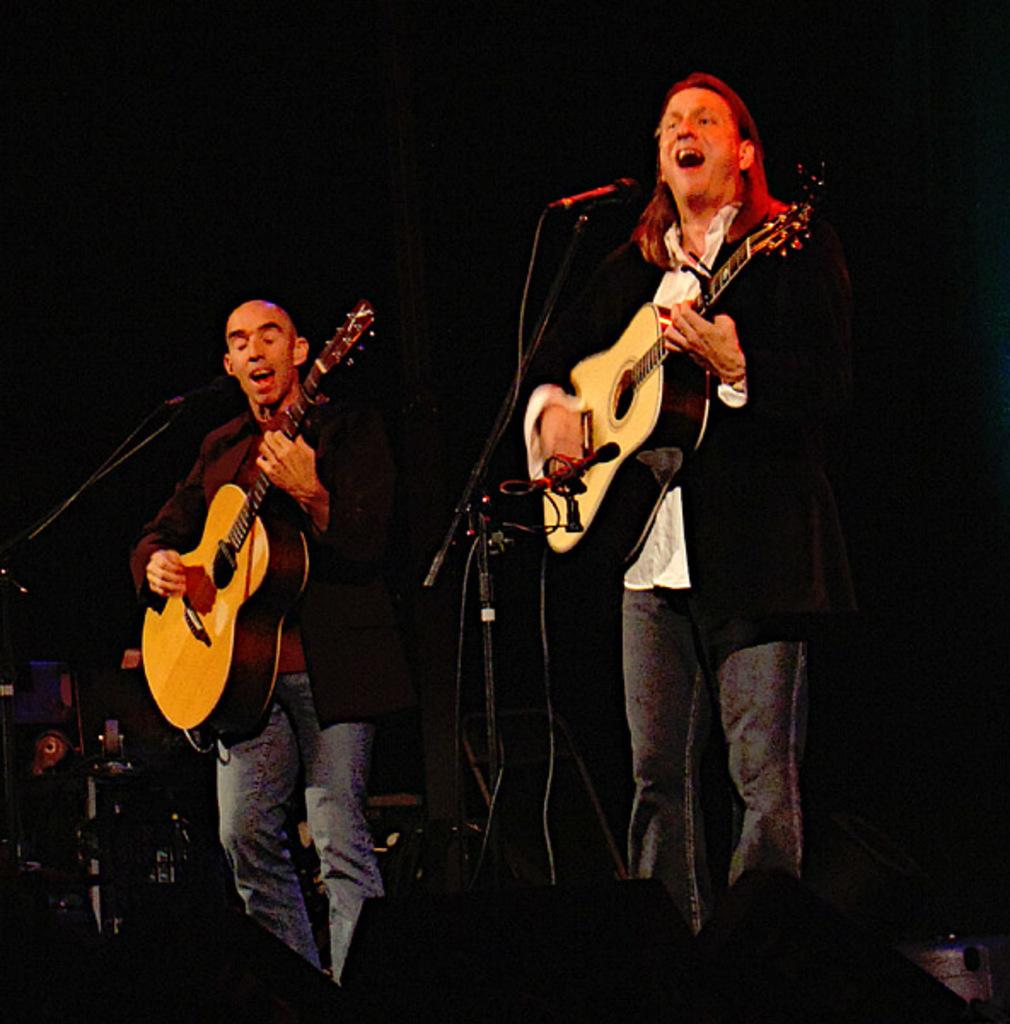What is the person in the image doing? The person is playing music in the image. What instrument is the person using to play music? The person is holding a guitar. Can you describe the person's facial expression? The person's mouth is open. What else can be seen in the image related to music? There are musical instruments on the left side of the image. How many babies are crawling on the floor in the image? There are no babies present in the image; it features a person playing music with a guitar. What type of stem is visible in the image? There is no stem visible in the image. 